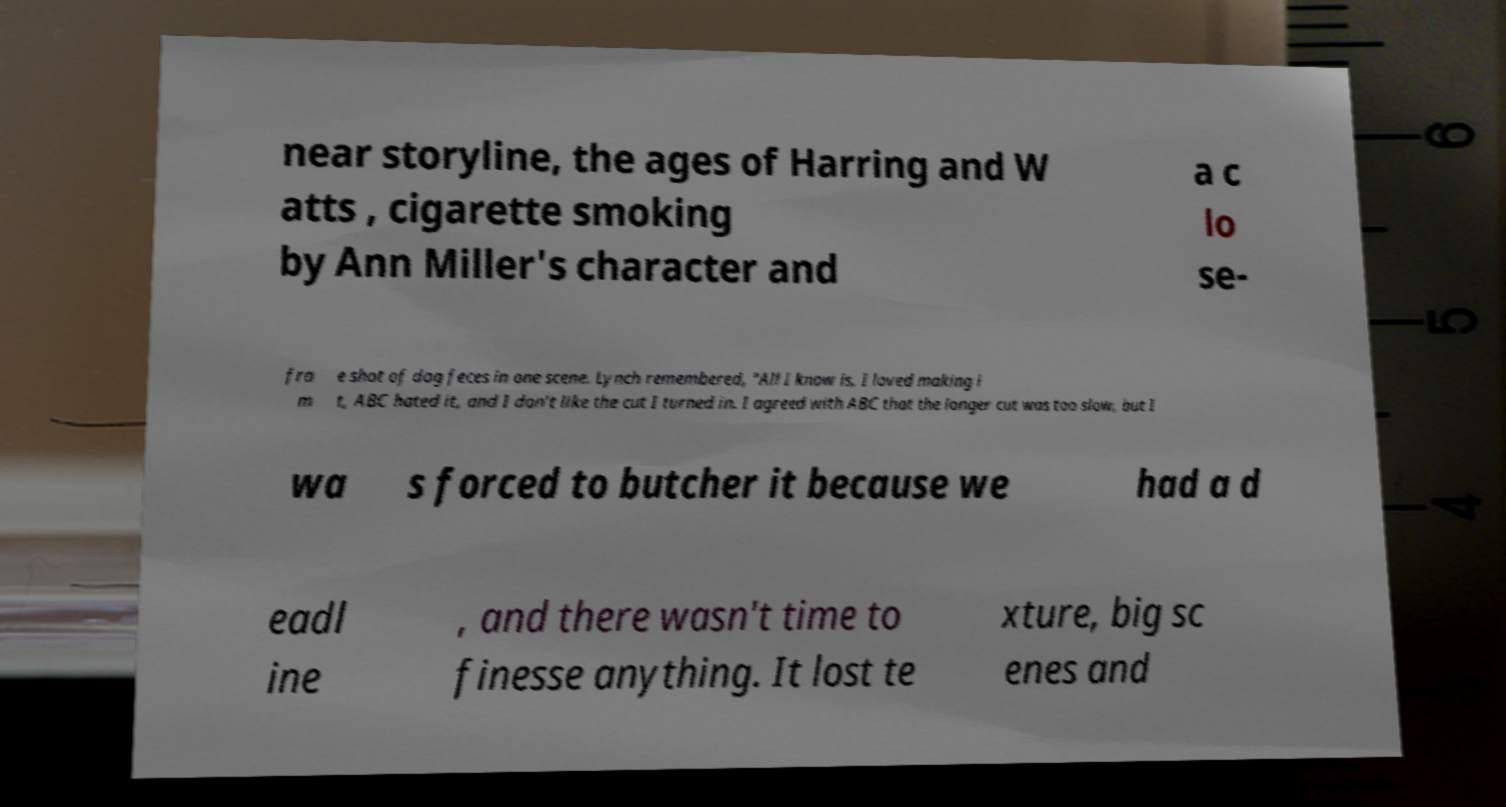Could you assist in decoding the text presented in this image and type it out clearly? near storyline, the ages of Harring and W atts , cigarette smoking by Ann Miller's character and a c lo se- fra m e shot of dog feces in one scene. Lynch remembered, "All I know is, I loved making i t, ABC hated it, and I don't like the cut I turned in. I agreed with ABC that the longer cut was too slow, but I wa s forced to butcher it because we had a d eadl ine , and there wasn't time to finesse anything. It lost te xture, big sc enes and 